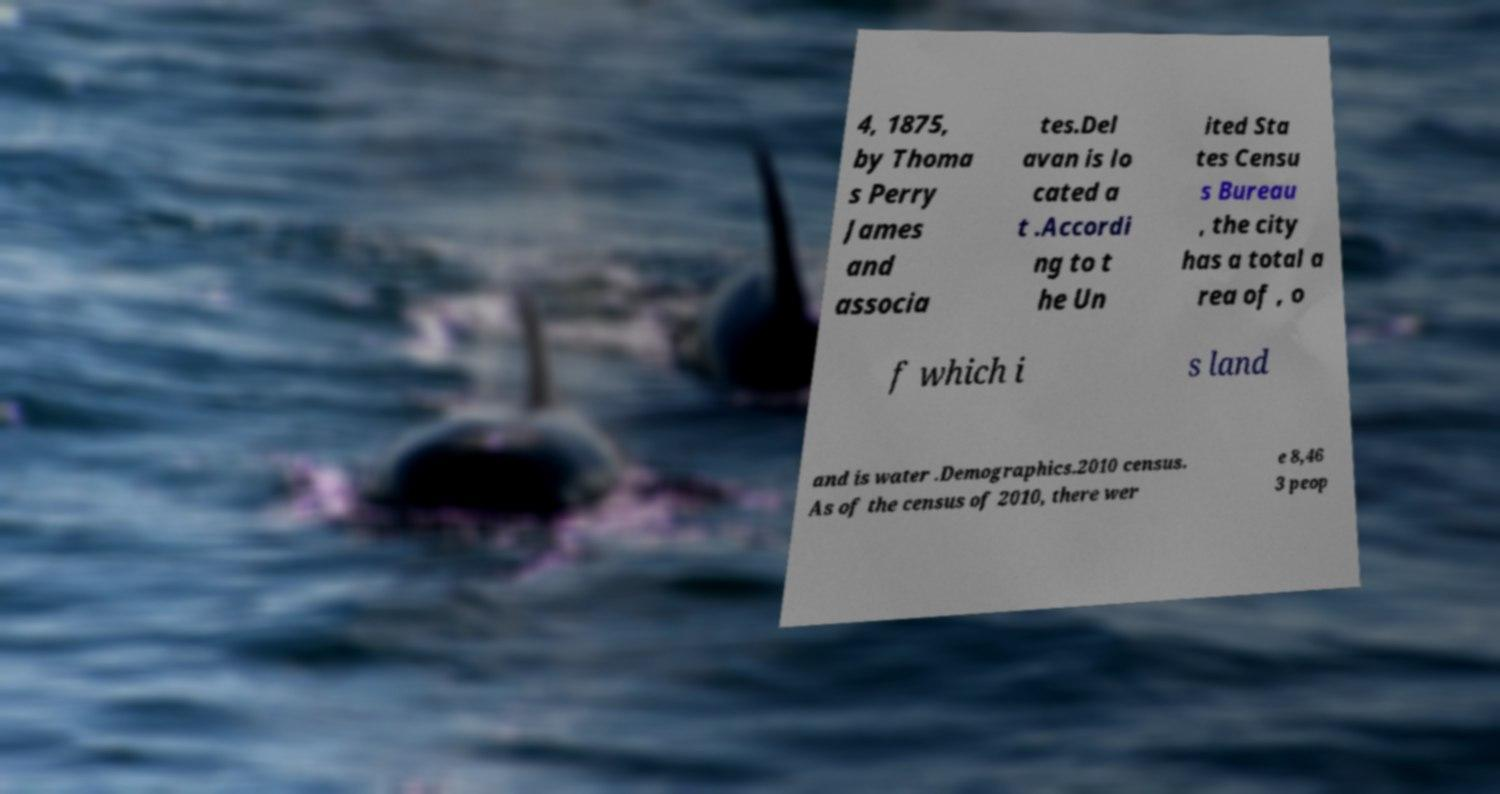Please identify and transcribe the text found in this image. 4, 1875, by Thoma s Perry James and associa tes.Del avan is lo cated a t .Accordi ng to t he Un ited Sta tes Censu s Bureau , the city has a total a rea of , o f which i s land and is water .Demographics.2010 census. As of the census of 2010, there wer e 8,46 3 peop 